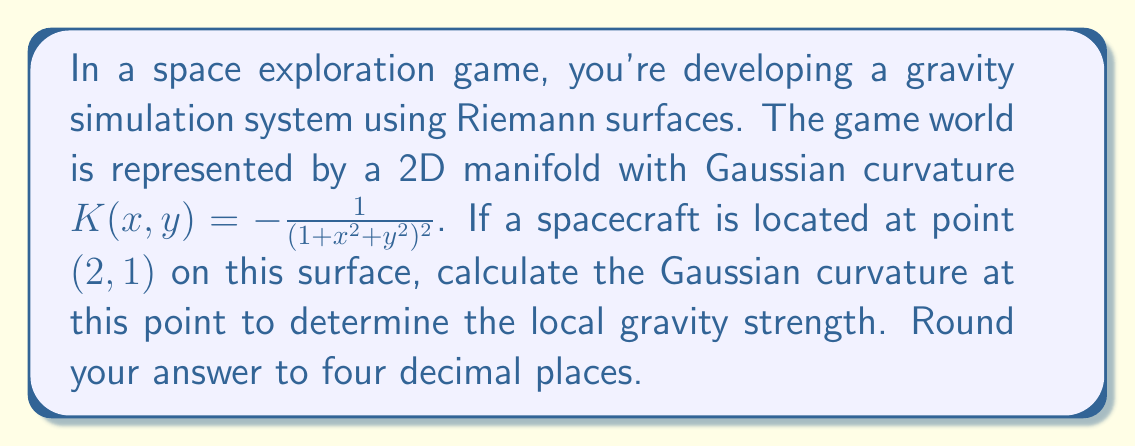Could you help me with this problem? To solve this problem, we'll follow these steps:

1) We're given the Gaussian curvature function:

   $$K(x,y) = -\frac{1}{(1+x^2+y^2)^2}$$

2) The spacecraft's location is at point $(2,1)$, so we need to calculate $K(2,1)$.

3) Let's substitute $x=2$ and $y=1$ into the equation:

   $$K(2,1) = -\frac{1}{(1+2^2+1^2)^2}$$

4) Simplify the expression inside the parentheses:
   
   $$K(2,1) = -\frac{1}{(1+4+1)^2} = -\frac{1}{6^2}$$

5) Calculate the final value:

   $$K(2,1) = -\frac{1}{36} \approx -0.0277777778$$

6) Rounding to four decimal places:

   $$K(2,1) \approx -0.0278$$

This negative curvature value indicates that the surface at this point is saddle-shaped, which would affect the local gravity simulation in the game.
Answer: $-0.0278$ 